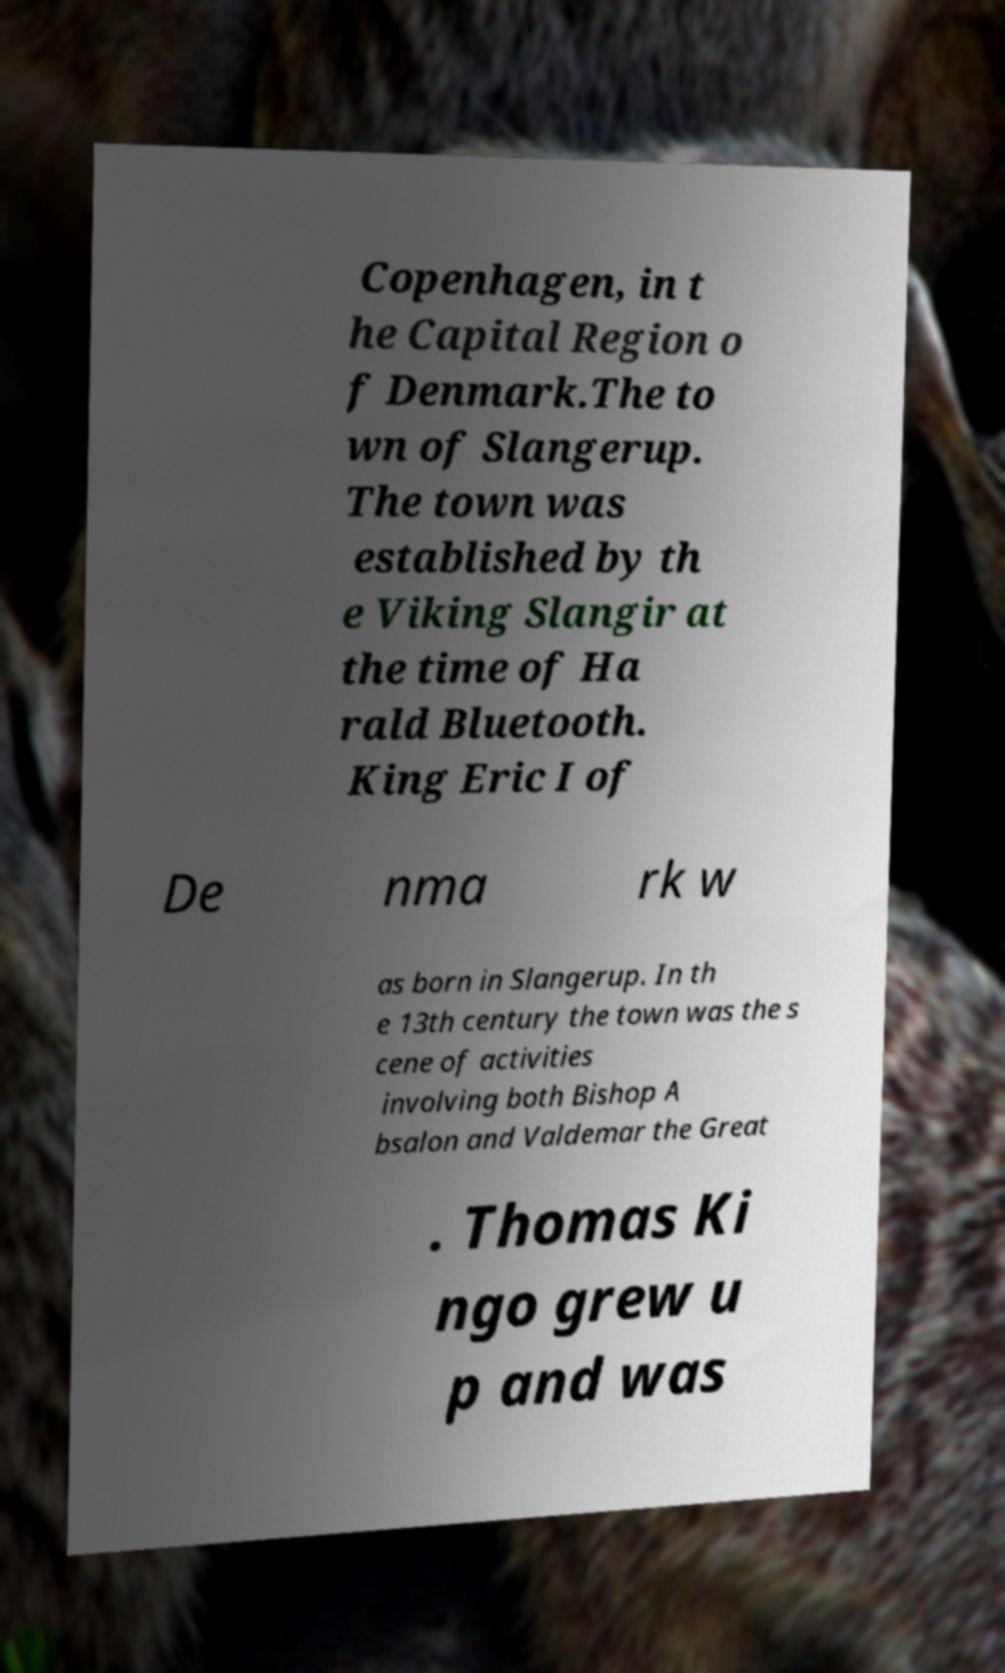There's text embedded in this image that I need extracted. Can you transcribe it verbatim? Copenhagen, in t he Capital Region o f Denmark.The to wn of Slangerup. The town was established by th e Viking Slangir at the time of Ha rald Bluetooth. King Eric I of De nma rk w as born in Slangerup. In th e 13th century the town was the s cene of activities involving both Bishop A bsalon and Valdemar the Great . Thomas Ki ngo grew u p and was 